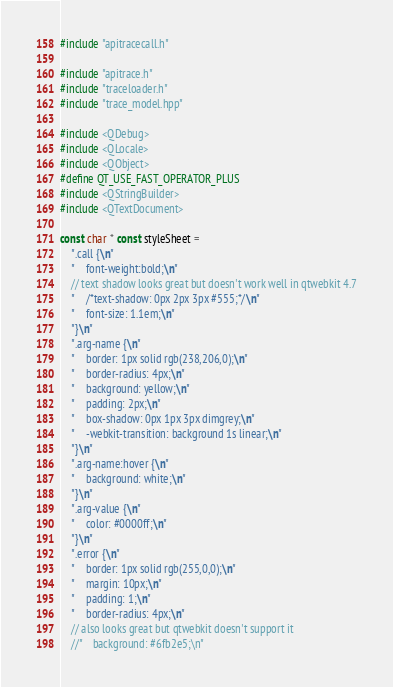Convert code to text. <code><loc_0><loc_0><loc_500><loc_500><_C++_>#include "apitracecall.h"

#include "apitrace.h"
#include "traceloader.h"
#include "trace_model.hpp"

#include <QDebug>
#include <QLocale>
#include <QObject>
#define QT_USE_FAST_OPERATOR_PLUS
#include <QStringBuilder>
#include <QTextDocument>

const char * const styleSheet =
    ".call {\n"
    "    font-weight:bold;\n"
    // text shadow looks great but doesn't work well in qtwebkit 4.7
    "    /*text-shadow: 0px 2px 3px #555;*/\n"
    "    font-size: 1.1em;\n"
    "}\n"
    ".arg-name {\n"
    "    border: 1px solid rgb(238,206,0);\n"
    "    border-radius: 4px;\n"
    "    background: yellow;\n"
    "    padding: 2px;\n"
    "    box-shadow: 0px 1px 3px dimgrey;\n"
    "    -webkit-transition: background 1s linear;\n"
    "}\n"
    ".arg-name:hover {\n"
    "    background: white;\n"
    "}\n"
    ".arg-value {\n"
    "    color: #0000ff;\n"
    "}\n"
    ".error {\n"
    "    border: 1px solid rgb(255,0,0);\n"
    "    margin: 10px;\n"
    "    padding: 1;\n"
    "    border-radius: 4px;\n"
    // also looks great but qtwebkit doesn't support it
    //"    background: #6fb2e5;\n"</code> 